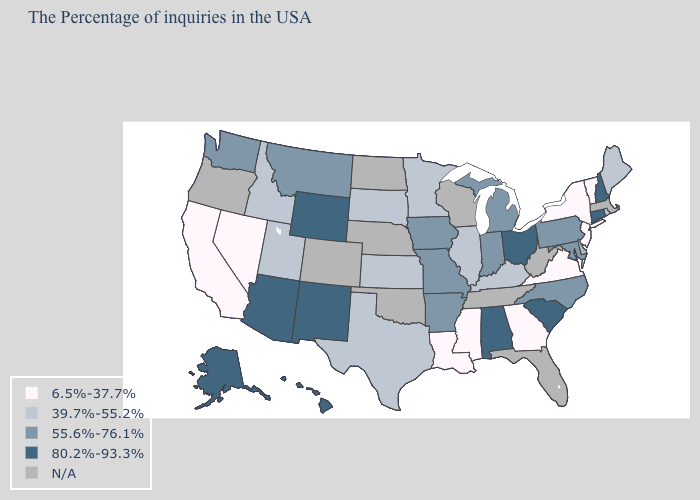What is the value of Kansas?
Short answer required. 39.7%-55.2%. Name the states that have a value in the range 39.7%-55.2%?
Keep it brief. Maine, Rhode Island, Kentucky, Illinois, Minnesota, Kansas, Texas, South Dakota, Utah, Idaho. What is the value of Alaska?
Give a very brief answer. 80.2%-93.3%. Name the states that have a value in the range 6.5%-37.7%?
Be succinct. Vermont, New York, New Jersey, Virginia, Georgia, Mississippi, Louisiana, Nevada, California. Does the map have missing data?
Keep it brief. Yes. Among the states that border New Mexico , does Utah have the lowest value?
Quick response, please. Yes. Among the states that border Delaware , which have the highest value?
Quick response, please. Maryland, Pennsylvania. What is the value of Massachusetts?
Give a very brief answer. N/A. What is the value of Texas?
Quick response, please. 39.7%-55.2%. What is the highest value in the South ?
Keep it brief. 80.2%-93.3%. 